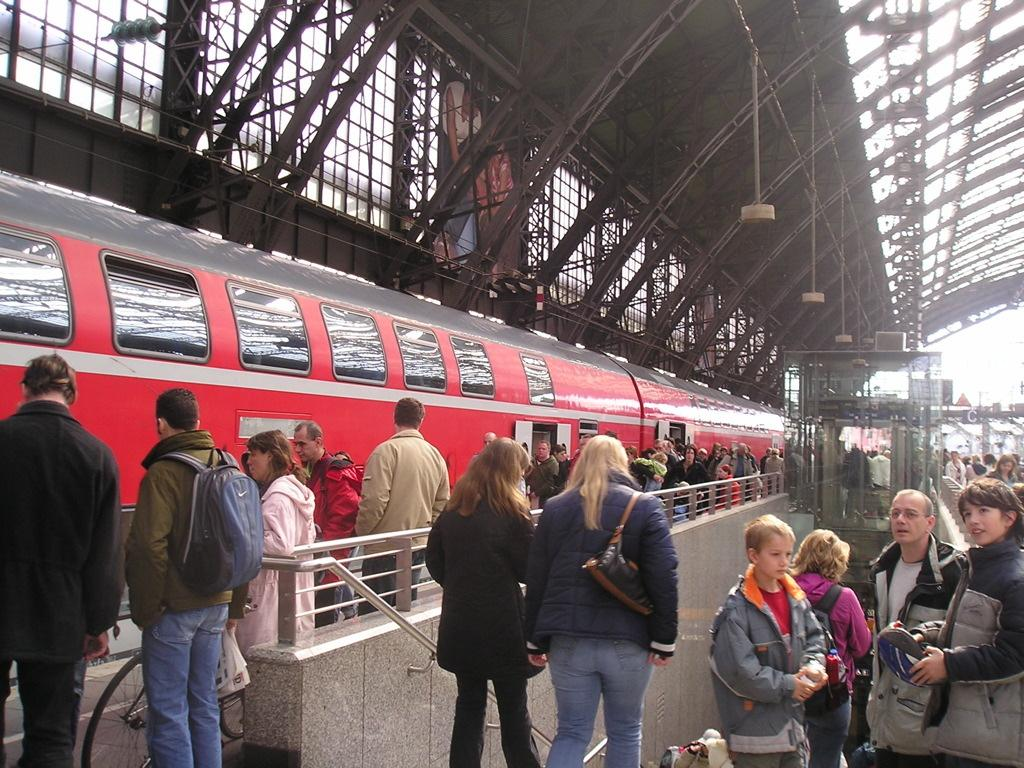What is the setting of the image? The setting of the image is a railway station platform. What type of train can be seen in the image? There is a red color train in the image. Can you describe the people in the picture? There are men and women in the picture. What is the digestion process of the train in the image? There is no digestion process for the train in the image, as trains do not have a digestive system. How many feet are visible in the image? There is no specific number of feet visible in the image, as the focus is on the people and the train. 